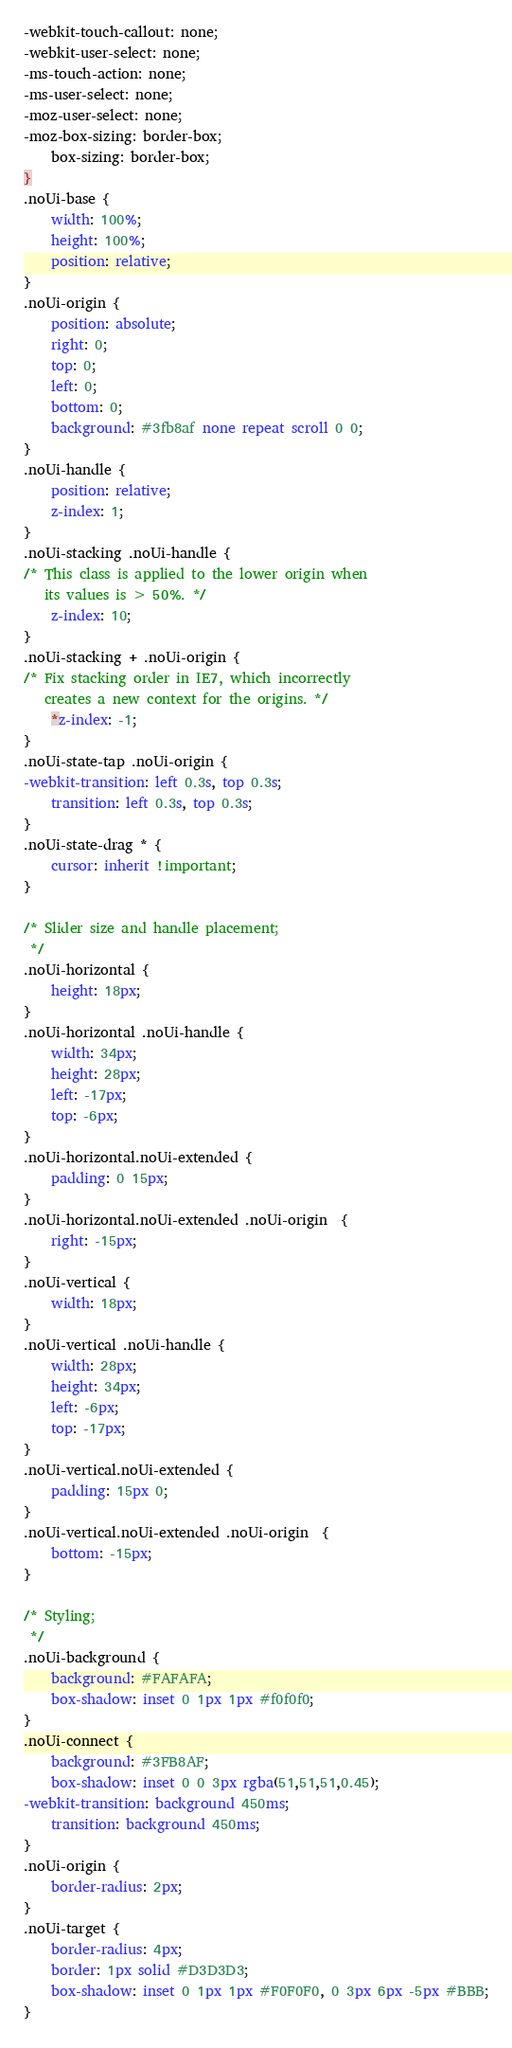<code> <loc_0><loc_0><loc_500><loc_500><_CSS_>-webkit-touch-callout: none;
-webkit-user-select: none;
-ms-touch-action: none;
-ms-user-select: none;
-moz-user-select: none;
-moz-box-sizing: border-box;
	box-sizing: border-box;
}
.noUi-base {
	width: 100%;
	height: 100%;
	position: relative;
}
.noUi-origin {
	position: absolute;
	right: 0;
	top: 0;
	left: 0;
	bottom: 0;
	background: #3fb8af none repeat scroll 0 0;
}
.noUi-handle {
	position: relative;
	z-index: 1;
}
.noUi-stacking .noUi-handle {
/* This class is applied to the lower origin when
   its values is > 50%. */
	z-index: 10;
}
.noUi-stacking + .noUi-origin {
/* Fix stacking order in IE7, which incorrectly
   creates a new context for the origins. */
	*z-index: -1;
}
.noUi-state-tap .noUi-origin {
-webkit-transition: left 0.3s, top 0.3s;
	transition: left 0.3s, top 0.3s;
}
.noUi-state-drag * {
	cursor: inherit !important;
}

/* Slider size and handle placement;
 */
.noUi-horizontal {
	height: 18px;
}
.noUi-horizontal .noUi-handle {
	width: 34px;
	height: 28px;
	left: -17px;
	top: -6px;
}
.noUi-horizontal.noUi-extended {
	padding: 0 15px;
}
.noUi-horizontal.noUi-extended .noUi-origin  {
	right: -15px;
}
.noUi-vertical {
	width: 18px;
}
.noUi-vertical .noUi-handle {
	width: 28px;
	height: 34px;
	left: -6px;
	top: -17px;
}
.noUi-vertical.noUi-extended {
	padding: 15px 0;
}
.noUi-vertical.noUi-extended .noUi-origin  {
	bottom: -15px;
}

/* Styling;
 */
.noUi-background {
	background: #FAFAFA;
	box-shadow: inset 0 1px 1px #f0f0f0;
}
.noUi-connect {
	background: #3FB8AF;
	box-shadow: inset 0 0 3px rgba(51,51,51,0.45);
-webkit-transition: background 450ms;
	transition: background 450ms;
}
.noUi-origin {
	border-radius: 2px;
}
.noUi-target {
	border-radius: 4px;
	border: 1px solid #D3D3D3;
	box-shadow: inset 0 1px 1px #F0F0F0, 0 3px 6px -5px #BBB;
}</code> 